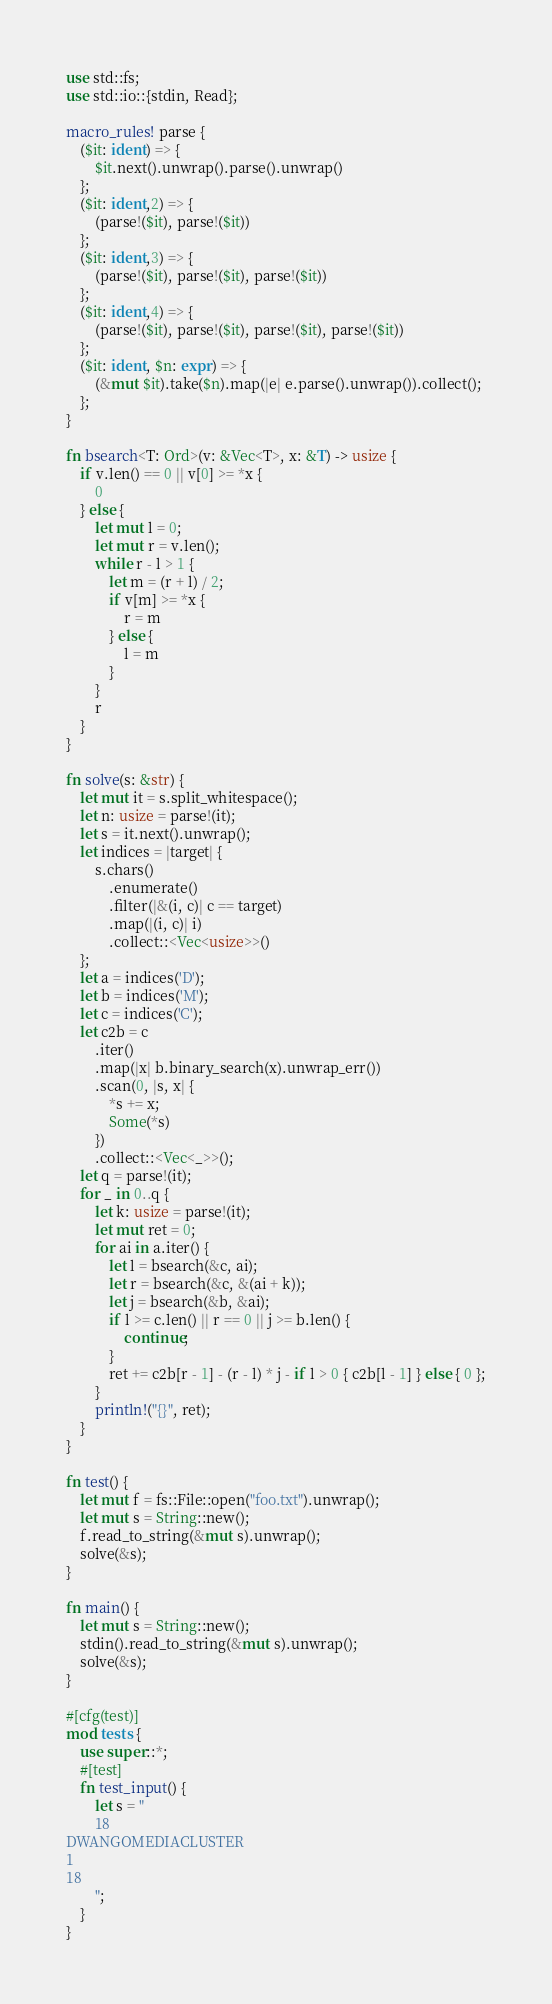<code> <loc_0><loc_0><loc_500><loc_500><_Rust_>use std::fs;
use std::io::{stdin, Read};

macro_rules! parse {
    ($it: ident) => {
        $it.next().unwrap().parse().unwrap()
    };
    ($it: ident,2) => {
        (parse!($it), parse!($it))
    };
    ($it: ident,3) => {
        (parse!($it), parse!($it), parse!($it))
    };
    ($it: ident,4) => {
        (parse!($it), parse!($it), parse!($it), parse!($it))
    };
    ($it: ident, $n: expr) => {
        (&mut $it).take($n).map(|e| e.parse().unwrap()).collect();
    };
}

fn bsearch<T: Ord>(v: &Vec<T>, x: &T) -> usize {
    if v.len() == 0 || v[0] >= *x {
        0
    } else {
        let mut l = 0;
        let mut r = v.len();
        while r - l > 1 {
            let m = (r + l) / 2;
            if v[m] >= *x {
                r = m
            } else {
                l = m
            }
        }
        r
    }
}

fn solve(s: &str) {
    let mut it = s.split_whitespace();
    let n: usize = parse!(it);
    let s = it.next().unwrap();
    let indices = |target| {
        s.chars()
            .enumerate()
            .filter(|&(i, c)| c == target)
            .map(|(i, c)| i)
            .collect::<Vec<usize>>()
    };
    let a = indices('D');
    let b = indices('M');
    let c = indices('C');
    let c2b = c
        .iter()
        .map(|x| b.binary_search(x).unwrap_err())
        .scan(0, |s, x| {
            *s += x;
            Some(*s)
        })
        .collect::<Vec<_>>();
    let q = parse!(it);
    for _ in 0..q {
        let k: usize = parse!(it);
        let mut ret = 0;
        for ai in a.iter() {
            let l = bsearch(&c, ai);
            let r = bsearch(&c, &(ai + k));
            let j = bsearch(&b, &ai);
            if l >= c.len() || r == 0 || j >= b.len() {
                continue;
            }
            ret += c2b[r - 1] - (r - l) * j - if l > 0 { c2b[l - 1] } else { 0 };
        }
        println!("{}", ret);
    }
}

fn test() {
    let mut f = fs::File::open("foo.txt").unwrap();
    let mut s = String::new();
    f.read_to_string(&mut s).unwrap();
    solve(&s);
}

fn main() {
    let mut s = String::new();
    stdin().read_to_string(&mut s).unwrap();
    solve(&s);
}

#[cfg(test)]
mod tests {
    use super::*;
    #[test]
    fn test_input() {
        let s = "
        18
DWANGOMEDIACLUSTER
1
18
        ";
    }
}
</code> 